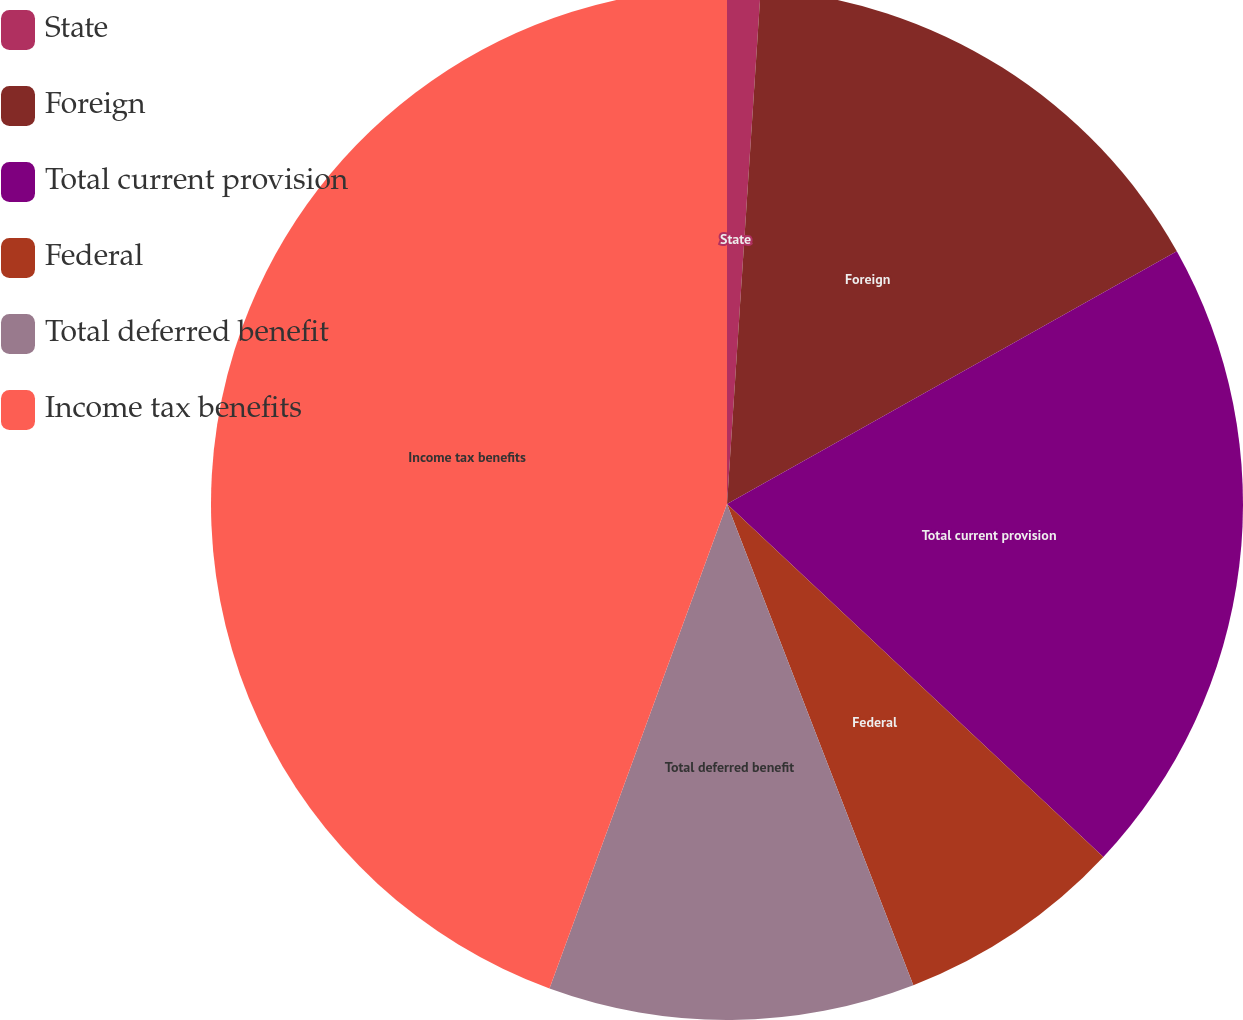Convert chart to OTSL. <chart><loc_0><loc_0><loc_500><loc_500><pie_chart><fcel>State<fcel>Foreign<fcel>Total current provision<fcel>Federal<fcel>Total deferred benefit<fcel>Income tax benefits<nl><fcel>1.04%<fcel>15.81%<fcel>20.14%<fcel>7.13%<fcel>11.47%<fcel>44.41%<nl></chart> 